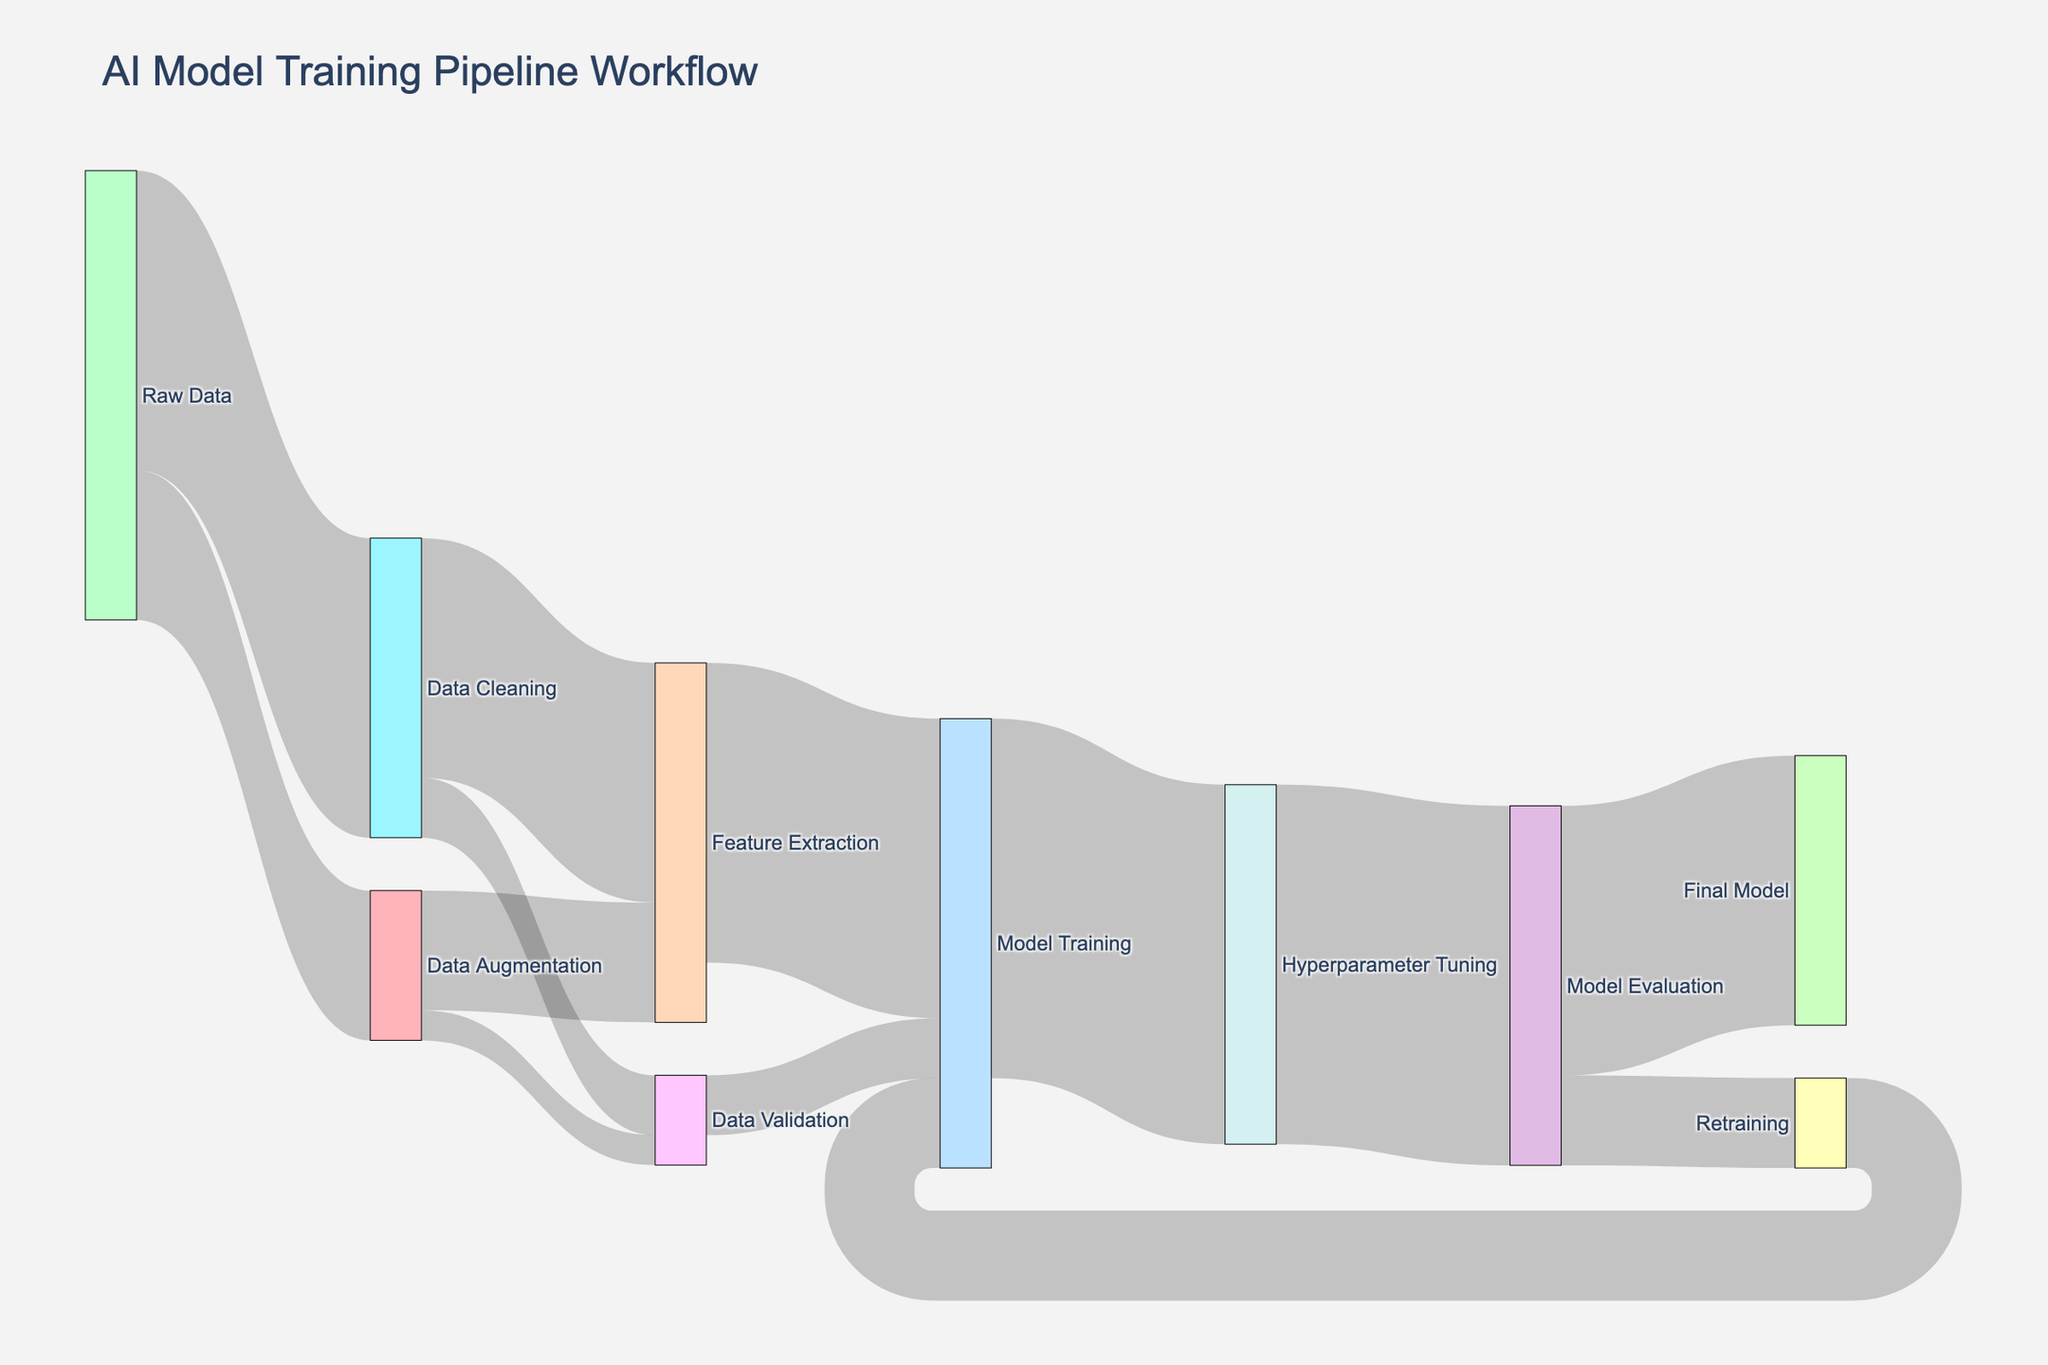What is the title of the figure? The title is usually found at the top center of the plot. The Sankey diagram's title is written in a larger font size compared to other texts on the plot.
Answer: AI Model Training Pipeline Workflow How many nodes are there in the Sankey diagram? Nodes are the different points where data moves from or to, labeled with certain states or processes like "Raw Data" and "Data Cleaning". By counting all the unique labels, we can figure out the total number of nodes. There are 13 unique nodes in the Sankey diagram.
Answer: 13 What is the total amount of data that eventually reaches the 'Final Model'? To find this, we need to follow the flow of data through the processes leading to 'Final Model'. From 'Model Evaluation', 900 units flow into the 'Final Model'.
Answer: 900 How much data is used for 'Feature Extraction'? Data flows into 'Feature Extraction' from both 'Data Cleaning' and 'Data Augmentation'. Adding the values from these sources gives us the total amount of data used for 'Feature Extraction'. Specifically, 800 (from 'Data Cleaning') + 400 (from 'Data Augmentation') = 1200.
Answer: 1200 Which process receives the highest amount of data and how much? To determine this, examine all the target nodes and compare the values flowing into them. 'Model Training' receives a total of 1000 (from 'Feature Extraction') + 200 (from 'Data Validation') = 1200, and 'Hyperparameter Tuning' then receives 1200 from 'Model Training'. Therefore, 'Hyperparameter Tuning' receives the highest with 1200 units of data.
Answer: Hyperparameter Tuning, 1200 How much data is sent from 'Data Augmentation' directly to 'Data Validation'? We can find this by looking at the flow values between 'Data Augmentation' and 'Data Validation' in the Sankey diagram. There is a flow of 100 units from 'Data Augmentation' to 'Data Validation'.
Answer: 100 What is the total data involved in the 'Model Training' stage including retraining? 'Model Training' initially receives 1000 (from 'Feature Extraction') + 200 (from 'Data Validation'). It gets another 300 from 'Retraining', making the total data involved in 'Model Training' 1200 + 300 = 1500.
Answer: 1500 How much data is moved from 'Hyperparameter Tuning' to 'Model Evaluation'? The flow from 'Hyperparameter Tuning' to 'Model Evaluation' is explicitly shown in the diagram. This value is 1200 units.
Answer: 1200 What process receives data from both 'Data Cleaning' and 'Data Augmentation'? By inspecting the target nodes that have incoming flows from both 'Data Cleaning' and 'Data Augmentation', we can identify that 'Feature Extraction' receives data from both of these processes.
Answer: Feature Extraction Which single source sends the most data into other processes, and what is the total amount sent? By examining all the sending nodes and summing up their outgoing values, 'Raw Data' sends 1000 (to 'Data Cleaning') + 500 (to 'Data Augmentation') = 1500 units, which is the highest among all sources.
Answer: Raw Data, 1500 